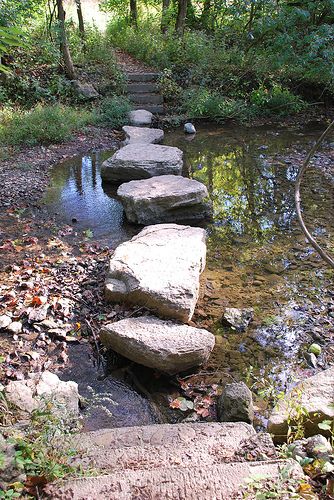<image>
Can you confirm if the stone is on the water? Yes. Looking at the image, I can see the stone is positioned on top of the water, with the water providing support. 